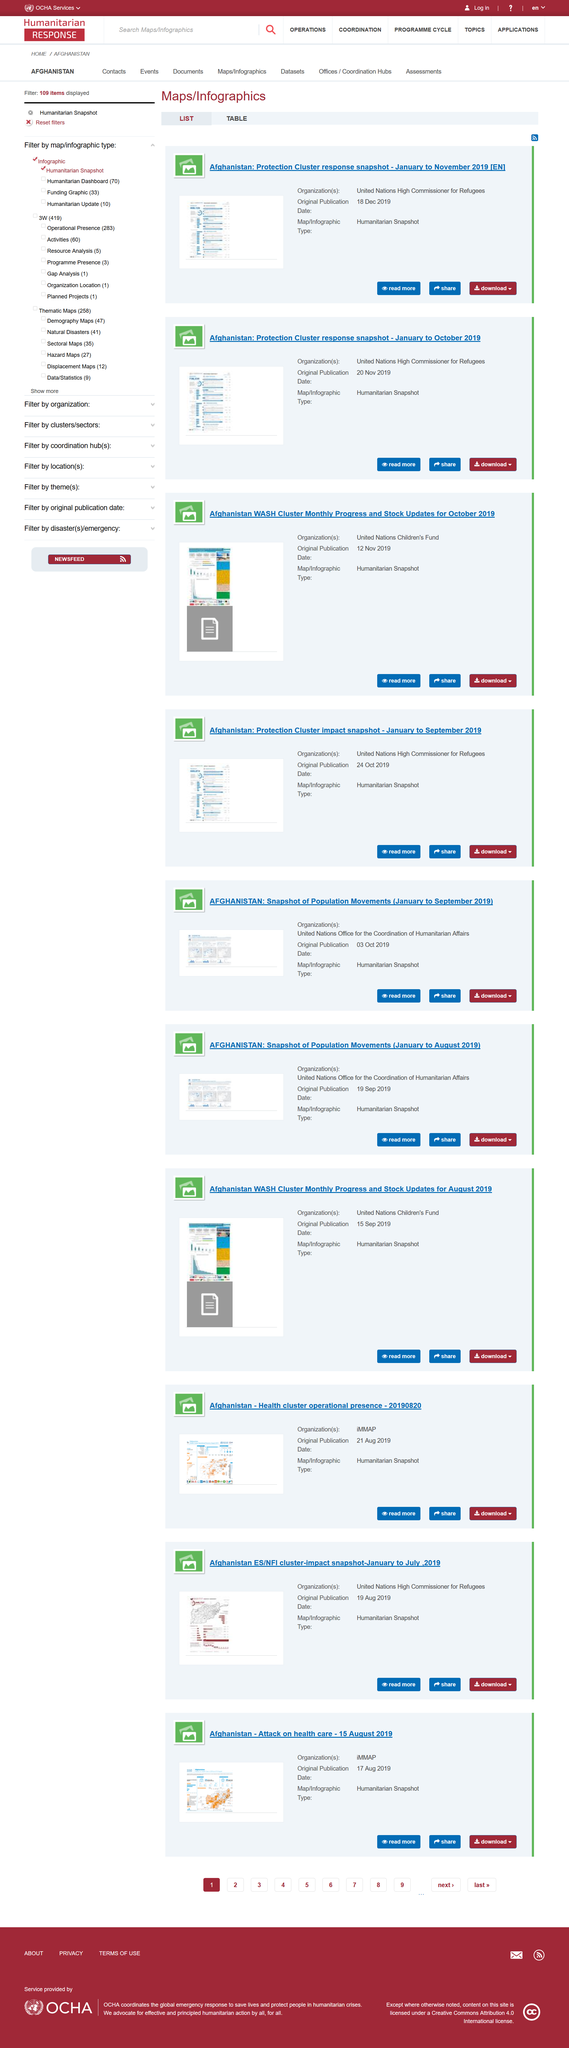Specify some key components in this picture. Yes, there is an option to download the publications. The document with an original publication date of 19 September 2019, titled "Afghanistan: Snapshot of Population Movements (January to August 2019)," is currently unavailable. The "Afghanistan: Protection Cluster response snapshot - January to October 2019" was originally published on November 20, 2019. The article on the attack on health care was originally published on August 17, 2019. iMMAP is the organization responsible for launching the attack on health care. 